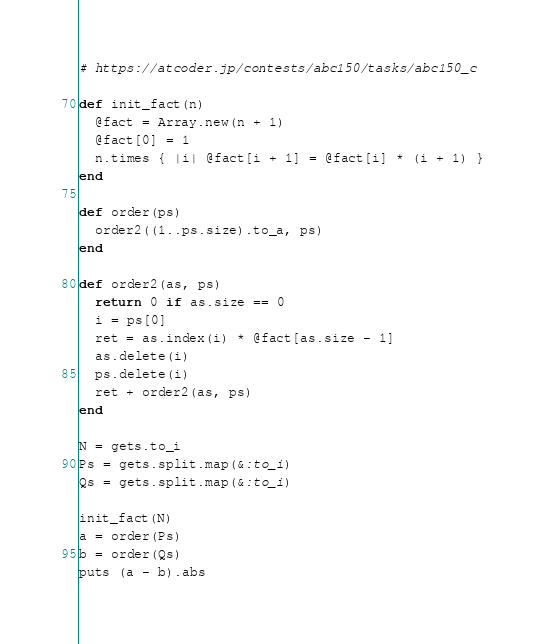Convert code to text. <code><loc_0><loc_0><loc_500><loc_500><_Ruby_># https://atcoder.jp/contests/abc150/tasks/abc150_c

def init_fact(n)
  @fact = Array.new(n + 1)
  @fact[0] = 1
  n.times { |i| @fact[i + 1] = @fact[i] * (i + 1) }
end

def order(ps)
  order2((1..ps.size).to_a, ps)
end

def order2(as, ps)
  return 0 if as.size == 0
  i = ps[0]
  ret = as.index(i) * @fact[as.size - 1]
  as.delete(i)
  ps.delete(i)
  ret + order2(as, ps)
end

N = gets.to_i
Ps = gets.split.map(&:to_i)
Qs = gets.split.map(&:to_i)

init_fact(N)
a = order(Ps)
b = order(Qs)
puts (a - b).abs
</code> 